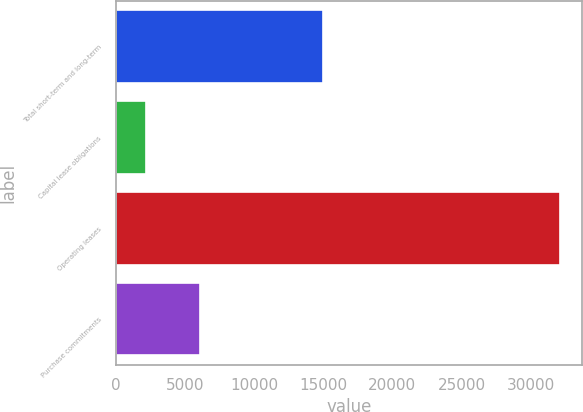Convert chart. <chart><loc_0><loc_0><loc_500><loc_500><bar_chart><fcel>Total short-term and long-term<fcel>Capital lease obligations<fcel>Operating leases<fcel>Purchase commitments<nl><fcel>15000<fcel>2202<fcel>32103<fcel>6099<nl></chart> 